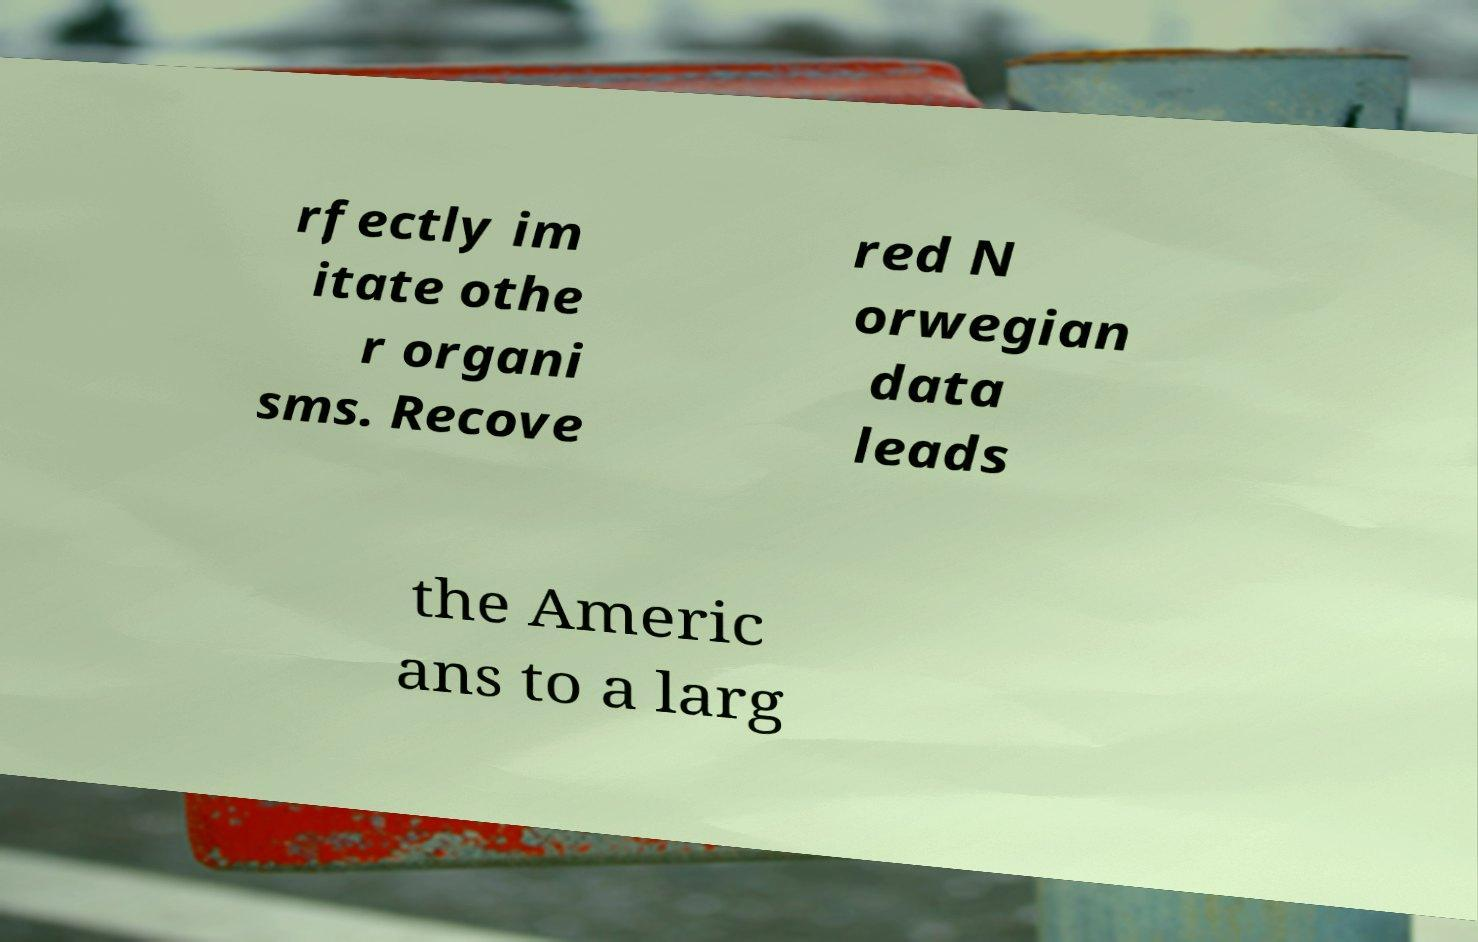Could you assist in decoding the text presented in this image and type it out clearly? rfectly im itate othe r organi sms. Recove red N orwegian data leads the Americ ans to a larg 